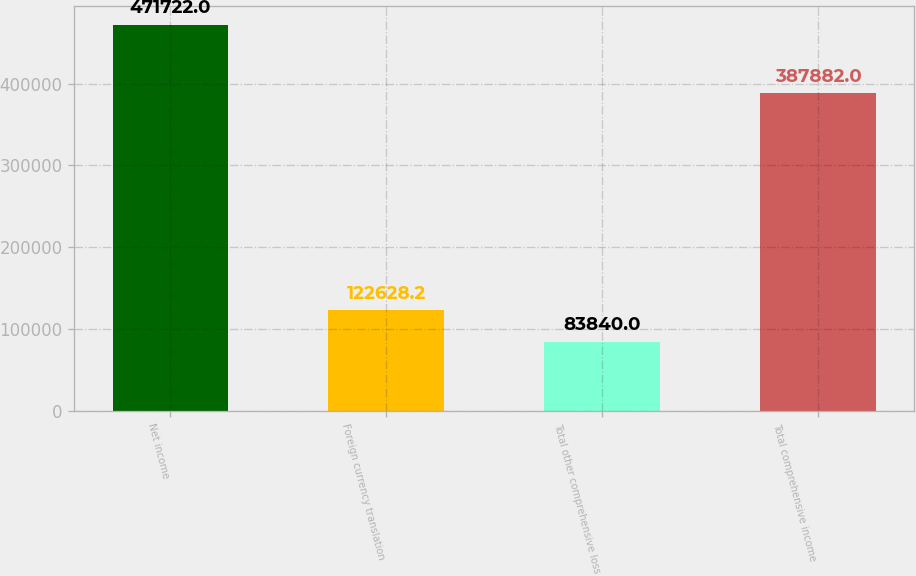<chart> <loc_0><loc_0><loc_500><loc_500><bar_chart><fcel>Net income<fcel>Foreign currency translation<fcel>Total other comprehensive loss<fcel>Total comprehensive income<nl><fcel>471722<fcel>122628<fcel>83840<fcel>387882<nl></chart> 